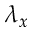Convert formula to latex. <formula><loc_0><loc_0><loc_500><loc_500>\lambda _ { x }</formula> 